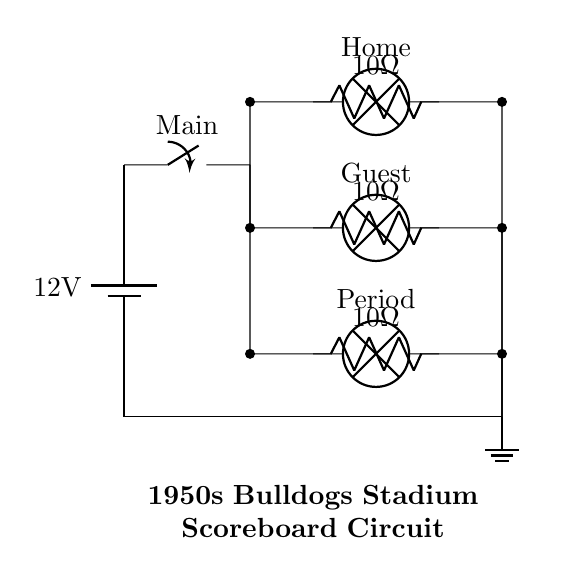What is the voltage supply for this circuit? The diagram shows a battery labeled with 12V, indicating that this is the supply voltage for the circuit.
Answer: 12 volts How many lamps are in this circuit? The circuit diagram indicates three lamps labeled Home, Guest, and Period, which represent the score/time indicators on the scoreboard.
Answer: Three What type of circuit configuration is used? The circuit shows parallel branches connecting the lamps, allowing each to operate independently from the others.
Answer: Parallel What is the resistance value for each lamp's branch? Each branch of the circuit features a resistor labeled with 10 ohms, indicating the resistance value for the lamps.
Answer: 10 ohms What happens to the lamps when the main switch is turned on? When the main switch is closed, current flows to all branches simultaneously, causing all lamps to illuminate.
Answer: All lamps illuminate If one lamp burns out, what will happen to the others? In a parallel configuration, if one lamp burns out (opens its circuit), the current can still flow through the other branches, allowing them to remain lit.
Answer: Others remain lit 